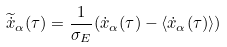Convert formula to latex. <formula><loc_0><loc_0><loc_500><loc_500>\widetilde { \dot { x } } _ { \alpha } ( \tau ) = \frac { 1 } { \sigma _ { E } } ( \dot { x } _ { \alpha } ( \tau ) - \langle \dot { x } _ { \alpha } ( \tau ) \rangle )</formula> 